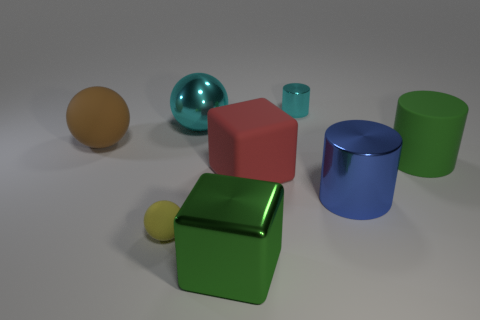There is a small object in front of the green matte cylinder; what is its color?
Your answer should be compact. Yellow. Is the number of tiny things behind the red rubber cube greater than the number of yellow objects to the right of the big matte cylinder?
Provide a succinct answer. Yes. What is the size of the cyan shiny thing that is to the right of the shiny object in front of the small object that is in front of the large brown object?
Your answer should be compact. Small. Are there any big shiny things of the same color as the rubber cylinder?
Offer a terse response. Yes. How many rubber objects are there?
Make the answer very short. 4. There is a sphere that is in front of the sphere that is on the left side of the matte sphere that is in front of the red cube; what is its material?
Your answer should be compact. Rubber. Are there any big objects that have the same material as the tiny yellow sphere?
Your answer should be compact. Yes. Is the tiny cyan cylinder made of the same material as the tiny ball?
Ensure brevity in your answer.  No. How many cubes are either big green things or tiny things?
Give a very brief answer. 1. There is a small thing that is made of the same material as the big blue thing; what is its color?
Give a very brief answer. Cyan. 